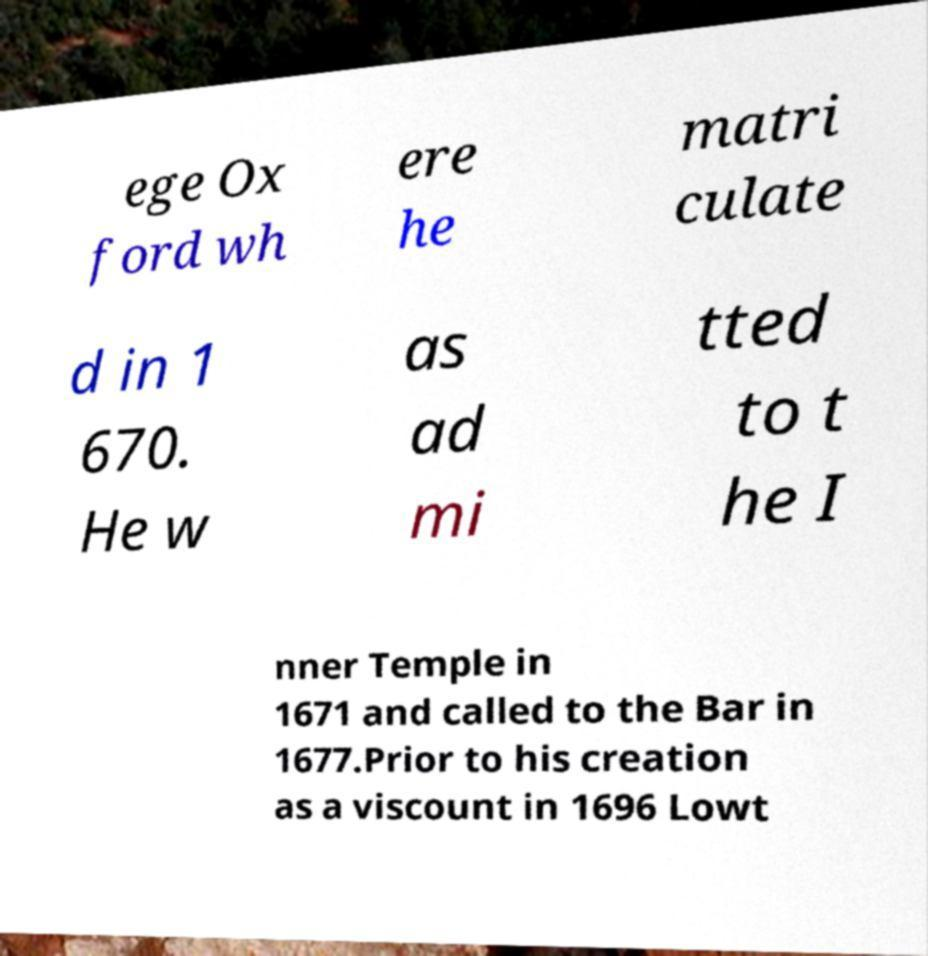Can you accurately transcribe the text from the provided image for me? ege Ox ford wh ere he matri culate d in 1 670. He w as ad mi tted to t he I nner Temple in 1671 and called to the Bar in 1677.Prior to his creation as a viscount in 1696 Lowt 